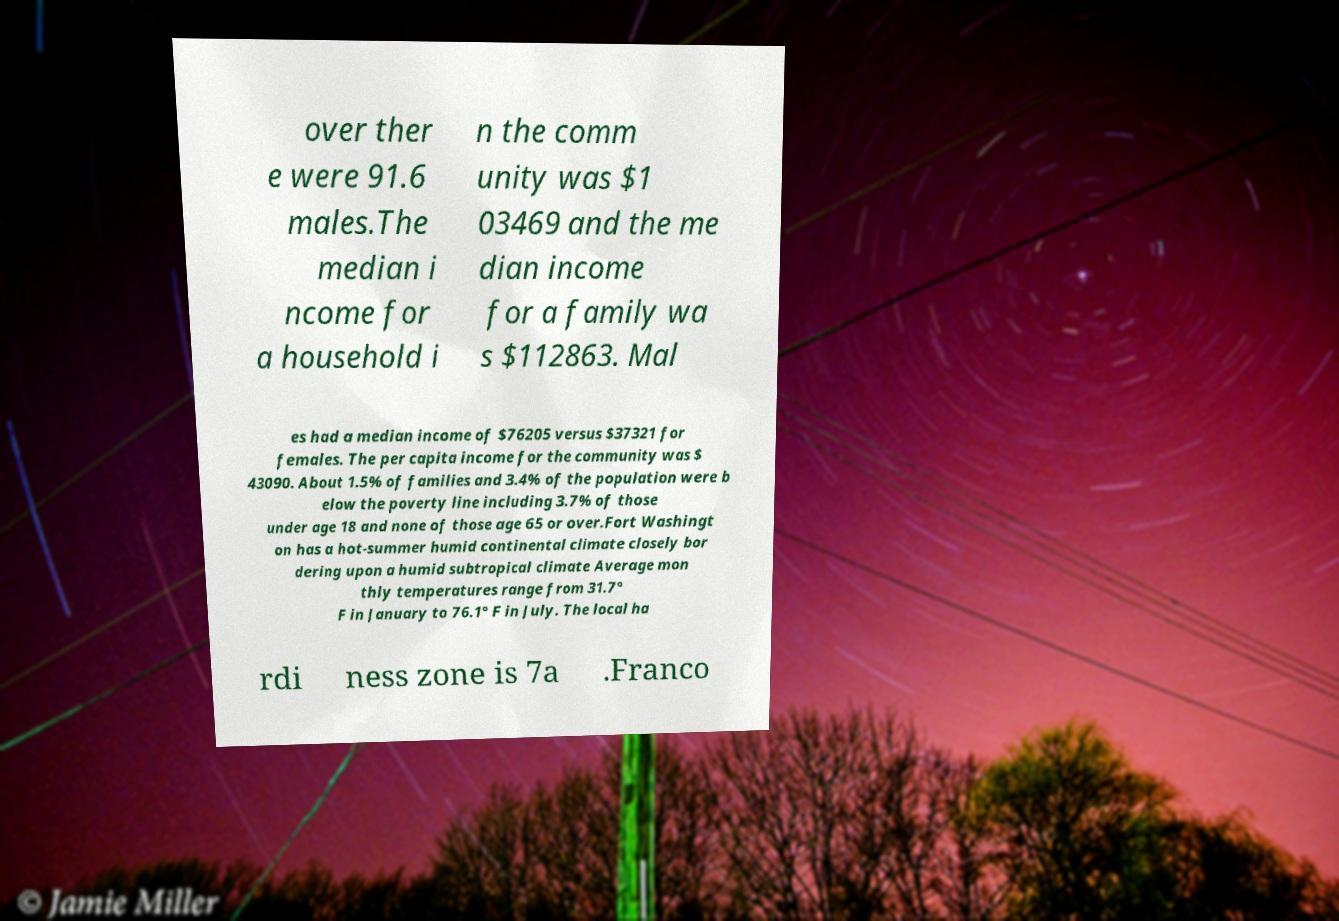Please read and relay the text visible in this image. What does it say? over ther e were 91.6 males.The median i ncome for a household i n the comm unity was $1 03469 and the me dian income for a family wa s $112863. Mal es had a median income of $76205 versus $37321 for females. The per capita income for the community was $ 43090. About 1.5% of families and 3.4% of the population were b elow the poverty line including 3.7% of those under age 18 and none of those age 65 or over.Fort Washingt on has a hot-summer humid continental climate closely bor dering upon a humid subtropical climate Average mon thly temperatures range from 31.7° F in January to 76.1° F in July. The local ha rdi ness zone is 7a .Franco 